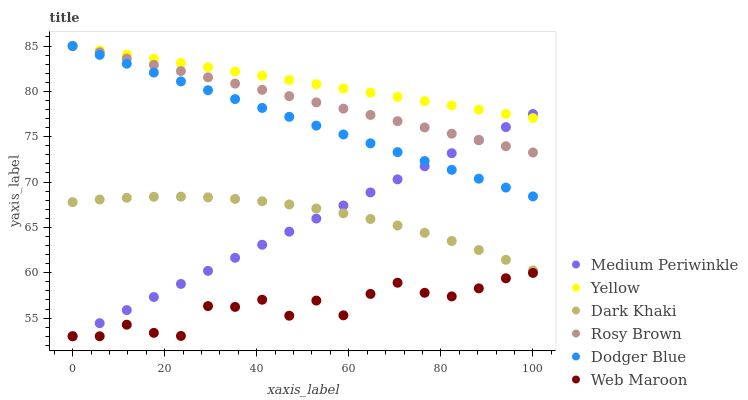Does Web Maroon have the minimum area under the curve?
Answer yes or no. Yes. Does Yellow have the maximum area under the curve?
Answer yes or no. Yes. Does Rosy Brown have the minimum area under the curve?
Answer yes or no. No. Does Rosy Brown have the maximum area under the curve?
Answer yes or no. No. Is Dodger Blue the smoothest?
Answer yes or no. Yes. Is Web Maroon the roughest?
Answer yes or no. Yes. Is Rosy Brown the smoothest?
Answer yes or no. No. Is Rosy Brown the roughest?
Answer yes or no. No. Does Web Maroon have the lowest value?
Answer yes or no. Yes. Does Rosy Brown have the lowest value?
Answer yes or no. No. Does Dodger Blue have the highest value?
Answer yes or no. Yes. Does Medium Periwinkle have the highest value?
Answer yes or no. No. Is Web Maroon less than Yellow?
Answer yes or no. Yes. Is Dodger Blue greater than Dark Khaki?
Answer yes or no. Yes. Does Rosy Brown intersect Yellow?
Answer yes or no. Yes. Is Rosy Brown less than Yellow?
Answer yes or no. No. Is Rosy Brown greater than Yellow?
Answer yes or no. No. Does Web Maroon intersect Yellow?
Answer yes or no. No. 